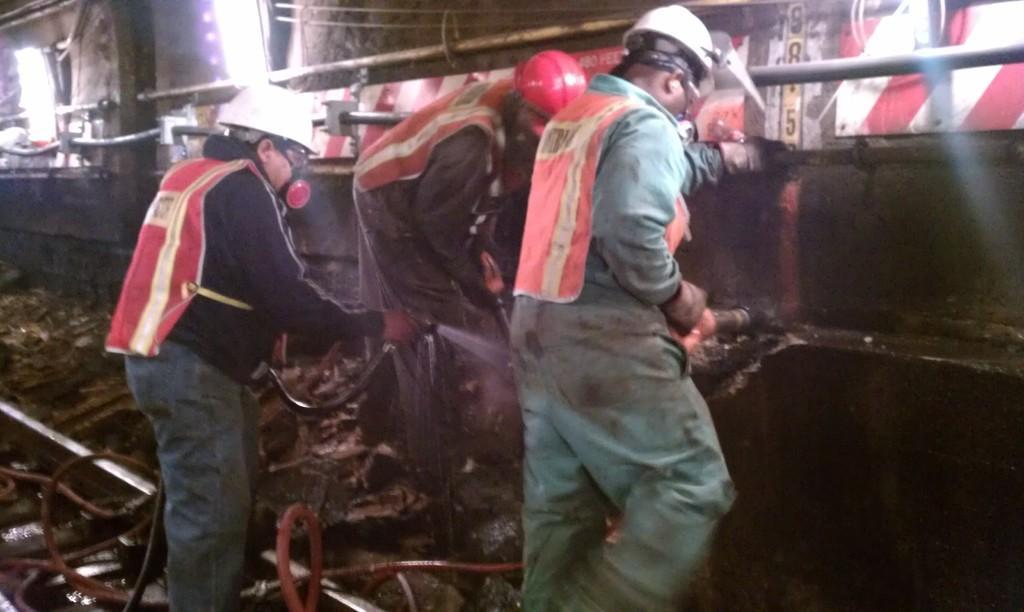Please provide a concise description of this image. In this image we can see three persons are holding pipes with their hands. Here we can see ground. In the background we can see wall, rods, and lights. 